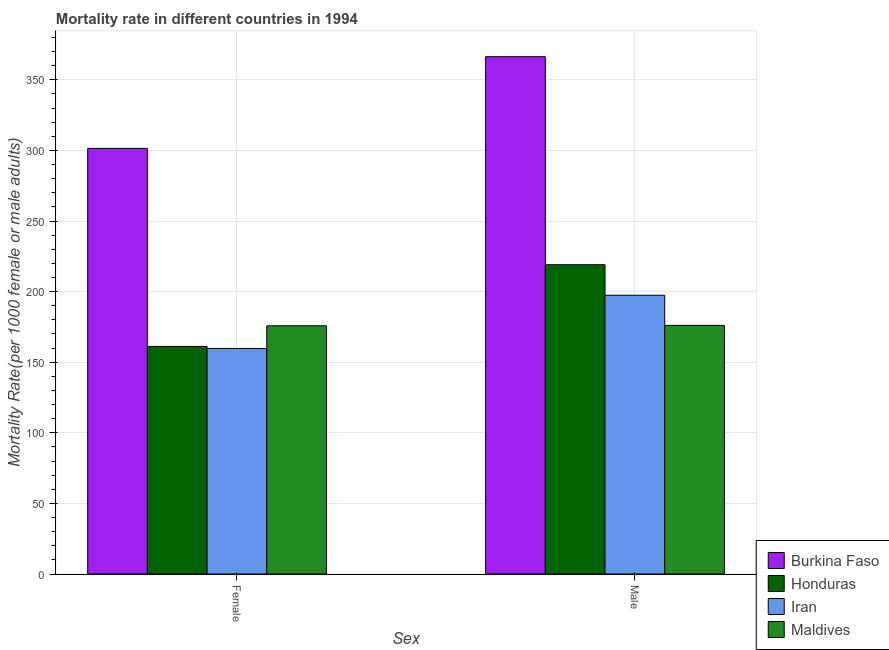Are the number of bars on each tick of the X-axis equal?
Offer a terse response. Yes. How many bars are there on the 2nd tick from the left?
Make the answer very short. 4. How many bars are there on the 1st tick from the right?
Keep it short and to the point. 4. What is the label of the 1st group of bars from the left?
Provide a short and direct response. Female. What is the male mortality rate in Honduras?
Your response must be concise. 219.06. Across all countries, what is the maximum male mortality rate?
Offer a terse response. 366.4. Across all countries, what is the minimum male mortality rate?
Provide a succinct answer. 176.09. In which country was the female mortality rate maximum?
Make the answer very short. Burkina Faso. In which country was the female mortality rate minimum?
Make the answer very short. Iran. What is the total male mortality rate in the graph?
Your answer should be very brief. 958.99. What is the difference between the female mortality rate in Iran and that in Honduras?
Offer a very short reply. -1.46. What is the difference between the female mortality rate in Maldives and the male mortality rate in Iran?
Your answer should be very brief. -21.63. What is the average male mortality rate per country?
Provide a succinct answer. 239.75. What is the difference between the male mortality rate and female mortality rate in Burkina Faso?
Your response must be concise. 64.95. In how many countries, is the male mortality rate greater than 90 ?
Provide a short and direct response. 4. What is the ratio of the female mortality rate in Burkina Faso to that in Maldives?
Your answer should be compact. 1.71. Is the female mortality rate in Iran less than that in Honduras?
Your answer should be very brief. Yes. In how many countries, is the female mortality rate greater than the average female mortality rate taken over all countries?
Provide a succinct answer. 1. What does the 2nd bar from the left in Female represents?
Offer a terse response. Honduras. What does the 3rd bar from the right in Male represents?
Keep it short and to the point. Honduras. How many bars are there?
Offer a terse response. 8. How many countries are there in the graph?
Provide a short and direct response. 4. Does the graph contain grids?
Offer a terse response. Yes. How many legend labels are there?
Your answer should be compact. 4. What is the title of the graph?
Give a very brief answer. Mortality rate in different countries in 1994. What is the label or title of the X-axis?
Ensure brevity in your answer.  Sex. What is the label or title of the Y-axis?
Offer a very short reply. Mortality Rate(per 1000 female or male adults). What is the Mortality Rate(per 1000 female or male adults) of Burkina Faso in Female?
Ensure brevity in your answer.  301.45. What is the Mortality Rate(per 1000 female or male adults) in Honduras in Female?
Your answer should be compact. 161.19. What is the Mortality Rate(per 1000 female or male adults) in Iran in Female?
Give a very brief answer. 159.74. What is the Mortality Rate(per 1000 female or male adults) in Maldives in Female?
Provide a succinct answer. 175.8. What is the Mortality Rate(per 1000 female or male adults) in Burkina Faso in Male?
Offer a very short reply. 366.4. What is the Mortality Rate(per 1000 female or male adults) of Honduras in Male?
Give a very brief answer. 219.06. What is the Mortality Rate(per 1000 female or male adults) in Iran in Male?
Ensure brevity in your answer.  197.43. What is the Mortality Rate(per 1000 female or male adults) in Maldives in Male?
Your answer should be compact. 176.09. Across all Sex, what is the maximum Mortality Rate(per 1000 female or male adults) of Burkina Faso?
Provide a short and direct response. 366.4. Across all Sex, what is the maximum Mortality Rate(per 1000 female or male adults) in Honduras?
Your answer should be compact. 219.06. Across all Sex, what is the maximum Mortality Rate(per 1000 female or male adults) in Iran?
Your answer should be very brief. 197.43. Across all Sex, what is the maximum Mortality Rate(per 1000 female or male adults) in Maldives?
Give a very brief answer. 176.09. Across all Sex, what is the minimum Mortality Rate(per 1000 female or male adults) of Burkina Faso?
Ensure brevity in your answer.  301.45. Across all Sex, what is the minimum Mortality Rate(per 1000 female or male adults) of Honduras?
Your response must be concise. 161.19. Across all Sex, what is the minimum Mortality Rate(per 1000 female or male adults) in Iran?
Your answer should be compact. 159.74. Across all Sex, what is the minimum Mortality Rate(per 1000 female or male adults) of Maldives?
Offer a terse response. 175.8. What is the total Mortality Rate(per 1000 female or male adults) in Burkina Faso in the graph?
Ensure brevity in your answer.  667.85. What is the total Mortality Rate(per 1000 female or male adults) of Honduras in the graph?
Your answer should be very brief. 380.26. What is the total Mortality Rate(per 1000 female or male adults) in Iran in the graph?
Offer a very short reply. 357.17. What is the total Mortality Rate(per 1000 female or male adults) in Maldives in the graph?
Your answer should be compact. 351.89. What is the difference between the Mortality Rate(per 1000 female or male adults) of Burkina Faso in Female and that in Male?
Ensure brevity in your answer.  -64.95. What is the difference between the Mortality Rate(per 1000 female or male adults) of Honduras in Female and that in Male?
Your answer should be compact. -57.87. What is the difference between the Mortality Rate(per 1000 female or male adults) in Iran in Female and that in Male?
Give a very brief answer. -37.69. What is the difference between the Mortality Rate(per 1000 female or male adults) of Maldives in Female and that in Male?
Make the answer very short. -0.29. What is the difference between the Mortality Rate(per 1000 female or male adults) of Burkina Faso in Female and the Mortality Rate(per 1000 female or male adults) of Honduras in Male?
Offer a terse response. 82.39. What is the difference between the Mortality Rate(per 1000 female or male adults) of Burkina Faso in Female and the Mortality Rate(per 1000 female or male adults) of Iran in Male?
Provide a short and direct response. 104.02. What is the difference between the Mortality Rate(per 1000 female or male adults) of Burkina Faso in Female and the Mortality Rate(per 1000 female or male adults) of Maldives in Male?
Offer a very short reply. 125.36. What is the difference between the Mortality Rate(per 1000 female or male adults) of Honduras in Female and the Mortality Rate(per 1000 female or male adults) of Iran in Male?
Give a very brief answer. -36.24. What is the difference between the Mortality Rate(per 1000 female or male adults) of Honduras in Female and the Mortality Rate(per 1000 female or male adults) of Maldives in Male?
Keep it short and to the point. -14.9. What is the difference between the Mortality Rate(per 1000 female or male adults) in Iran in Female and the Mortality Rate(per 1000 female or male adults) in Maldives in Male?
Make the answer very short. -16.36. What is the average Mortality Rate(per 1000 female or male adults) of Burkina Faso per Sex?
Make the answer very short. 333.92. What is the average Mortality Rate(per 1000 female or male adults) in Honduras per Sex?
Provide a succinct answer. 190.13. What is the average Mortality Rate(per 1000 female or male adults) in Iran per Sex?
Your answer should be very brief. 178.58. What is the average Mortality Rate(per 1000 female or male adults) of Maldives per Sex?
Provide a short and direct response. 175.95. What is the difference between the Mortality Rate(per 1000 female or male adults) of Burkina Faso and Mortality Rate(per 1000 female or male adults) of Honduras in Female?
Provide a short and direct response. 140.26. What is the difference between the Mortality Rate(per 1000 female or male adults) of Burkina Faso and Mortality Rate(per 1000 female or male adults) of Iran in Female?
Offer a very short reply. 141.71. What is the difference between the Mortality Rate(per 1000 female or male adults) of Burkina Faso and Mortality Rate(per 1000 female or male adults) of Maldives in Female?
Make the answer very short. 125.65. What is the difference between the Mortality Rate(per 1000 female or male adults) of Honduras and Mortality Rate(per 1000 female or male adults) of Iran in Female?
Keep it short and to the point. 1.46. What is the difference between the Mortality Rate(per 1000 female or male adults) in Honduras and Mortality Rate(per 1000 female or male adults) in Maldives in Female?
Your answer should be very brief. -14.61. What is the difference between the Mortality Rate(per 1000 female or male adults) of Iran and Mortality Rate(per 1000 female or male adults) of Maldives in Female?
Offer a terse response. -16.06. What is the difference between the Mortality Rate(per 1000 female or male adults) in Burkina Faso and Mortality Rate(per 1000 female or male adults) in Honduras in Male?
Give a very brief answer. 147.34. What is the difference between the Mortality Rate(per 1000 female or male adults) of Burkina Faso and Mortality Rate(per 1000 female or male adults) of Iran in Male?
Your answer should be compact. 168.97. What is the difference between the Mortality Rate(per 1000 female or male adults) in Burkina Faso and Mortality Rate(per 1000 female or male adults) in Maldives in Male?
Your answer should be very brief. 190.3. What is the difference between the Mortality Rate(per 1000 female or male adults) of Honduras and Mortality Rate(per 1000 female or male adults) of Iran in Male?
Your answer should be compact. 21.63. What is the difference between the Mortality Rate(per 1000 female or male adults) in Honduras and Mortality Rate(per 1000 female or male adults) in Maldives in Male?
Provide a succinct answer. 42.97. What is the difference between the Mortality Rate(per 1000 female or male adults) of Iran and Mortality Rate(per 1000 female or male adults) of Maldives in Male?
Your answer should be very brief. 21.34. What is the ratio of the Mortality Rate(per 1000 female or male adults) in Burkina Faso in Female to that in Male?
Your answer should be compact. 0.82. What is the ratio of the Mortality Rate(per 1000 female or male adults) in Honduras in Female to that in Male?
Make the answer very short. 0.74. What is the ratio of the Mortality Rate(per 1000 female or male adults) of Iran in Female to that in Male?
Give a very brief answer. 0.81. What is the ratio of the Mortality Rate(per 1000 female or male adults) in Maldives in Female to that in Male?
Your answer should be compact. 1. What is the difference between the highest and the second highest Mortality Rate(per 1000 female or male adults) in Burkina Faso?
Ensure brevity in your answer.  64.95. What is the difference between the highest and the second highest Mortality Rate(per 1000 female or male adults) in Honduras?
Your answer should be compact. 57.87. What is the difference between the highest and the second highest Mortality Rate(per 1000 female or male adults) of Iran?
Give a very brief answer. 37.69. What is the difference between the highest and the second highest Mortality Rate(per 1000 female or male adults) of Maldives?
Your answer should be compact. 0.29. What is the difference between the highest and the lowest Mortality Rate(per 1000 female or male adults) of Burkina Faso?
Offer a very short reply. 64.95. What is the difference between the highest and the lowest Mortality Rate(per 1000 female or male adults) of Honduras?
Make the answer very short. 57.87. What is the difference between the highest and the lowest Mortality Rate(per 1000 female or male adults) in Iran?
Keep it short and to the point. 37.69. What is the difference between the highest and the lowest Mortality Rate(per 1000 female or male adults) of Maldives?
Make the answer very short. 0.29. 